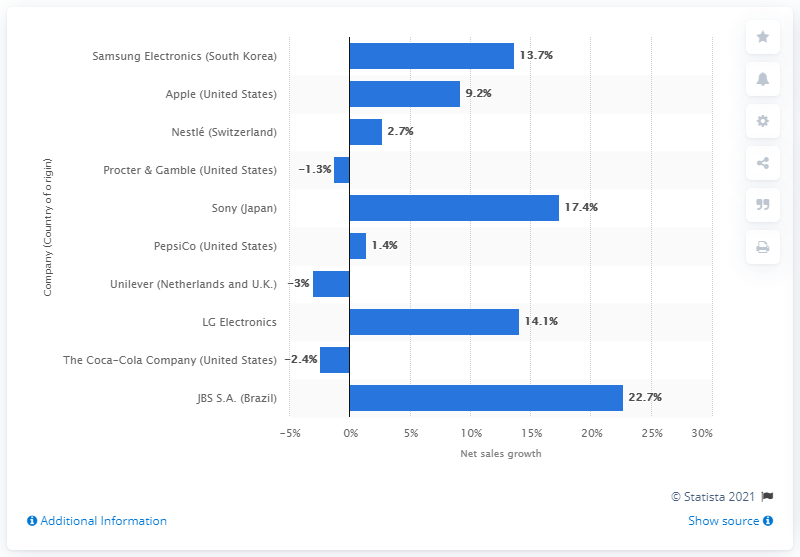Outline some significant characteristics in this image. In 2013, Apple's global net sales growth increased by 9.2%. 